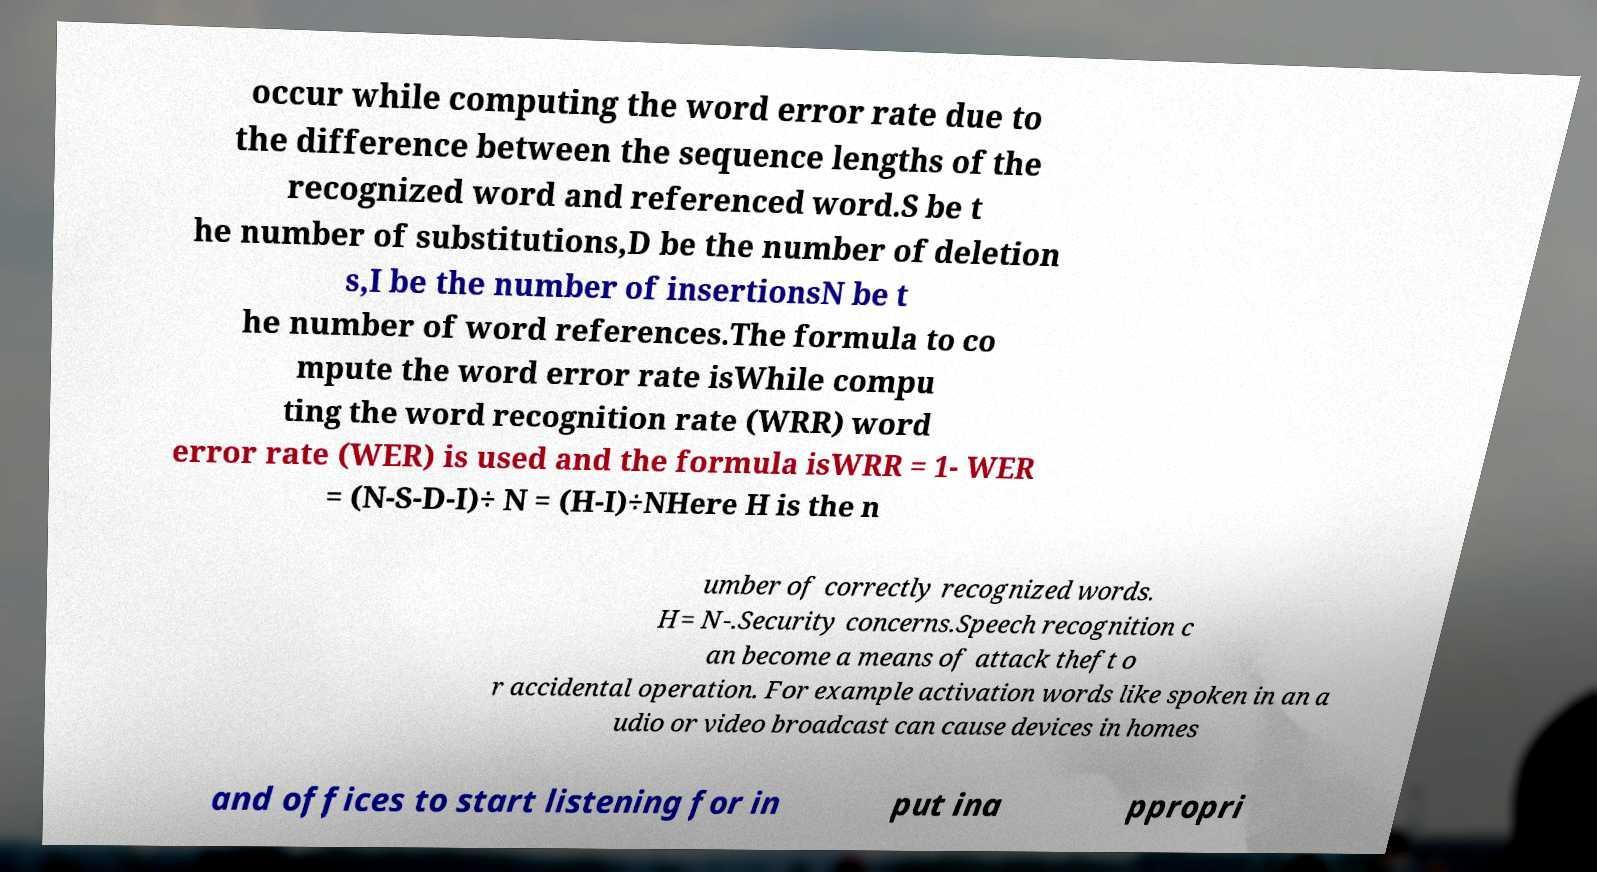Can you read and provide the text displayed in the image?This photo seems to have some interesting text. Can you extract and type it out for me? occur while computing the word error rate due to the difference between the sequence lengths of the recognized word and referenced word.S be t he number of substitutions,D be the number of deletion s,I be the number of insertionsN be t he number of word references.The formula to co mpute the word error rate isWhile compu ting the word recognition rate (WRR) word error rate (WER) is used and the formula isWRR = 1- WER = (N-S-D-I)÷ N = (H-I)÷NHere H is the n umber of correctly recognized words. H= N-.Security concerns.Speech recognition c an become a means of attack theft o r accidental operation. For example activation words like spoken in an a udio or video broadcast can cause devices in homes and offices to start listening for in put ina ppropri 